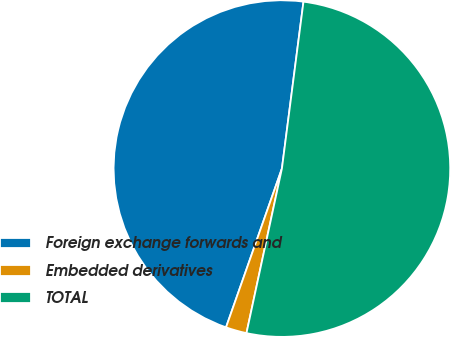Convert chart. <chart><loc_0><loc_0><loc_500><loc_500><pie_chart><fcel>Foreign exchange forwards and<fcel>Embedded derivatives<fcel>TOTAL<nl><fcel>46.66%<fcel>2.01%<fcel>51.33%<nl></chart> 